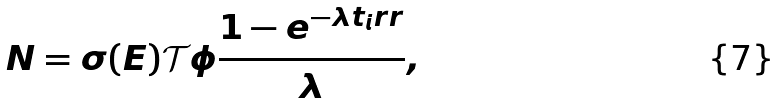<formula> <loc_0><loc_0><loc_500><loc_500>N = \sigma ( E ) \mathcal { T } \phi \frac { 1 - e ^ { - \lambda t _ { i } r r } } { \lambda } ,</formula> 